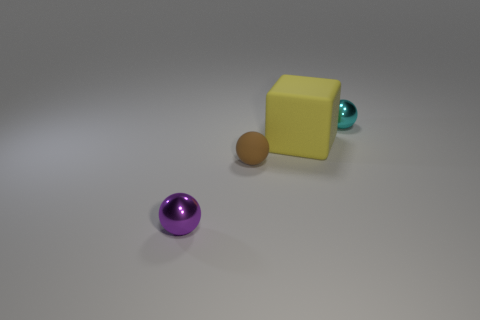Add 3 large yellow rubber cubes. How many objects exist? 7 Subtract all blocks. How many objects are left? 3 Subtract 1 purple spheres. How many objects are left? 3 Subtract all tiny objects. Subtract all gray shiny blocks. How many objects are left? 1 Add 2 brown matte spheres. How many brown matte spheres are left? 3 Add 1 tiny shiny things. How many tiny shiny things exist? 3 